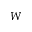<formula> <loc_0><loc_0><loc_500><loc_500>W</formula> 